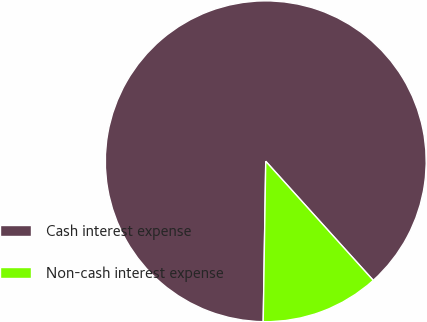<chart> <loc_0><loc_0><loc_500><loc_500><pie_chart><fcel>Cash interest expense<fcel>Non-cash interest expense<nl><fcel>88.06%<fcel>11.94%<nl></chart> 